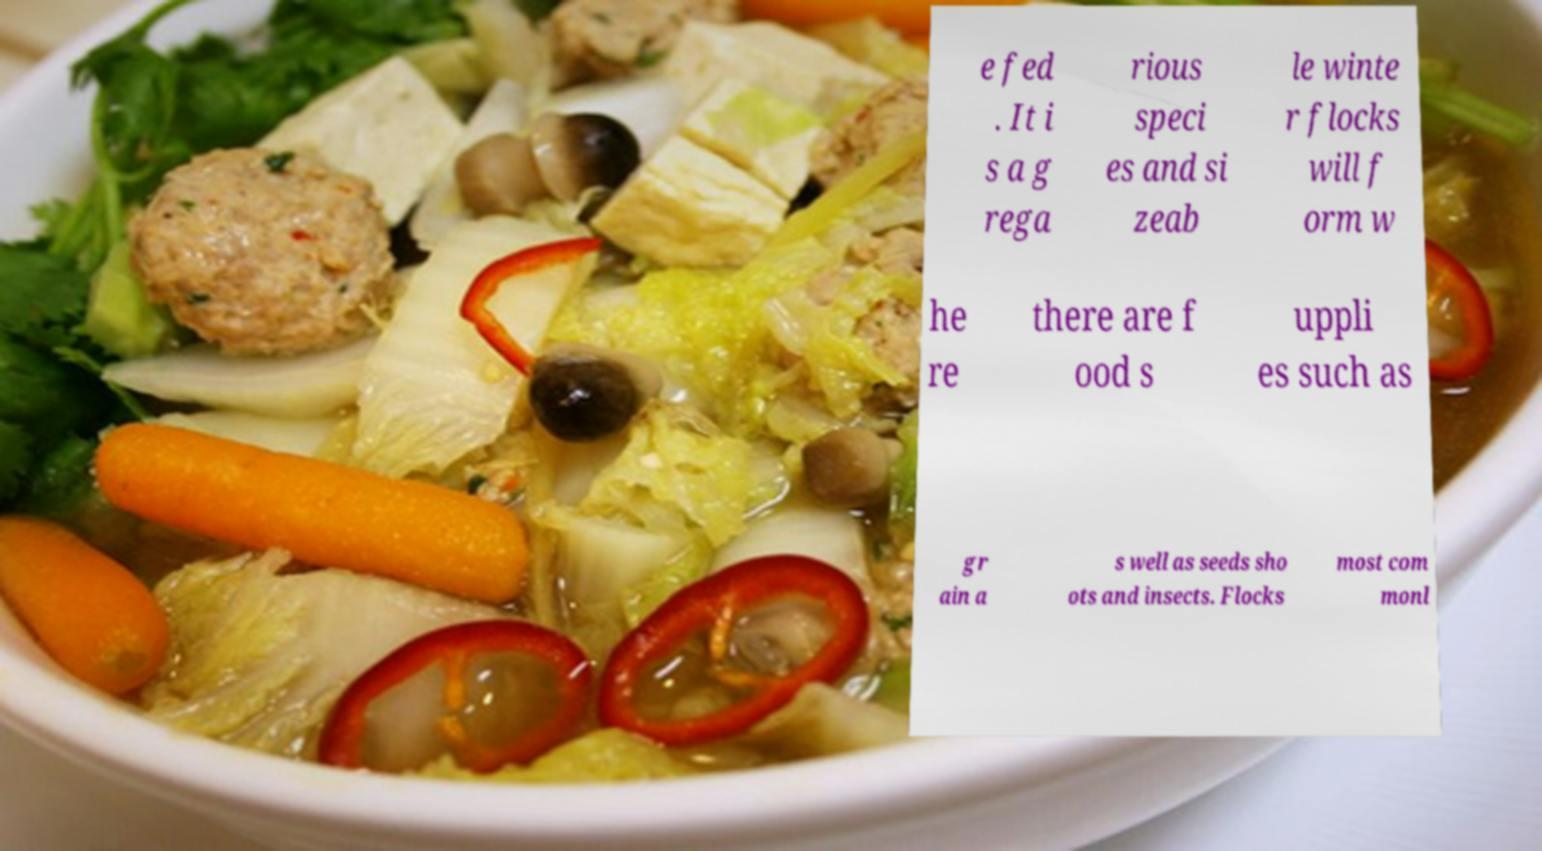Please identify and transcribe the text found in this image. e fed . It i s a g rega rious speci es and si zeab le winte r flocks will f orm w he re there are f ood s uppli es such as gr ain a s well as seeds sho ots and insects. Flocks most com monl 